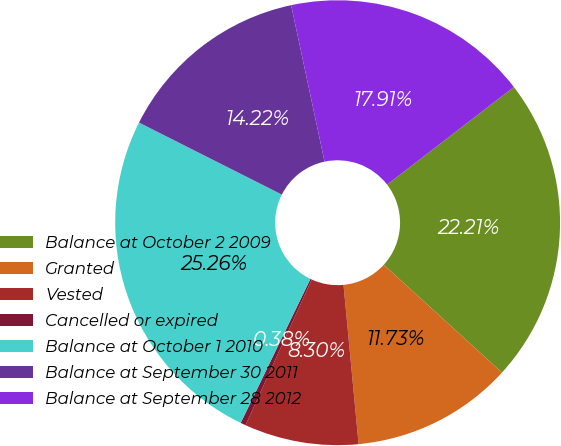Convert chart to OTSL. <chart><loc_0><loc_0><loc_500><loc_500><pie_chart><fcel>Balance at October 2 2009<fcel>Granted<fcel>Vested<fcel>Cancelled or expired<fcel>Balance at October 1 2010<fcel>Balance at September 30 2011<fcel>Balance at September 28 2012<nl><fcel>22.21%<fcel>11.73%<fcel>8.3%<fcel>0.38%<fcel>25.26%<fcel>14.22%<fcel>17.91%<nl></chart> 